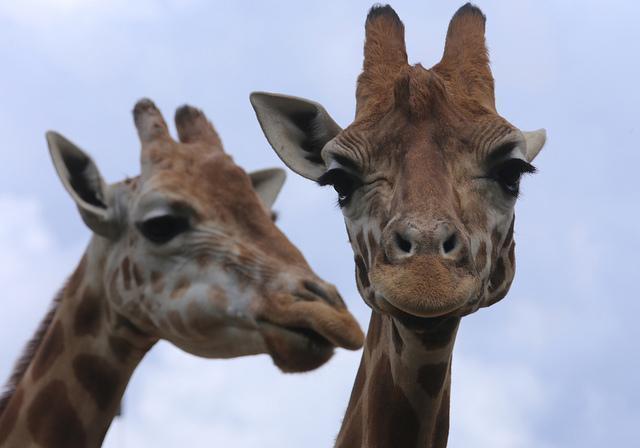How many ears do these animals have?
Give a very brief answer. 2. How many giraffes are there?
Give a very brief answer. 2. 